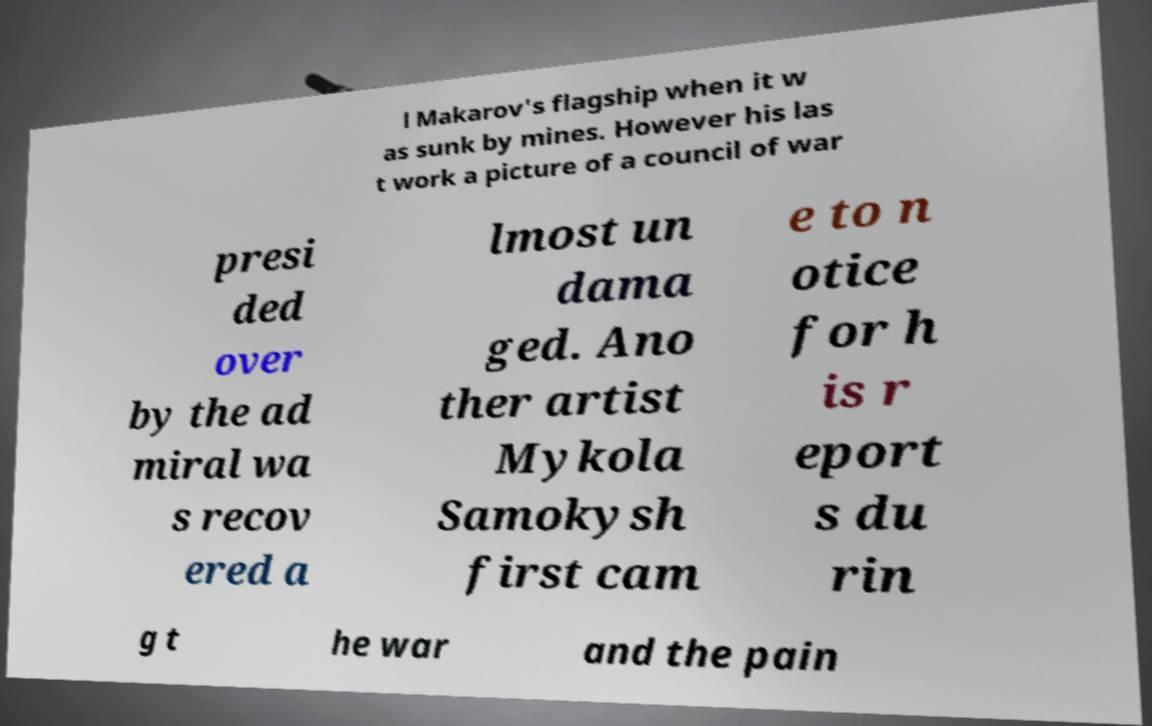Can you read and provide the text displayed in the image?This photo seems to have some interesting text. Can you extract and type it out for me? l Makarov's flagship when it w as sunk by mines. However his las t work a picture of a council of war presi ded over by the ad miral wa s recov ered a lmost un dama ged. Ano ther artist Mykola Samokysh first cam e to n otice for h is r eport s du rin g t he war and the pain 